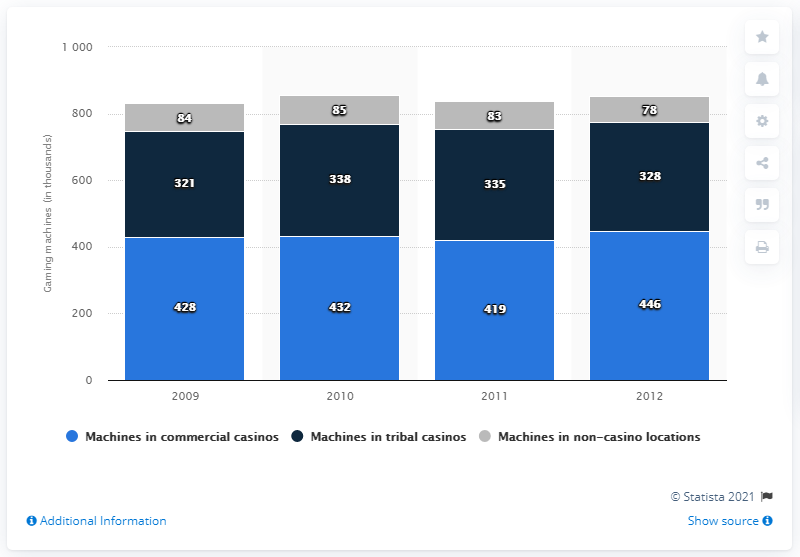Outline some significant characteristics in this image. In 2011, there were 27 more electronic gaming machines in commercial casinos compared to the previous year. The majority of electronic gaming machines are located in commercial casinos. 